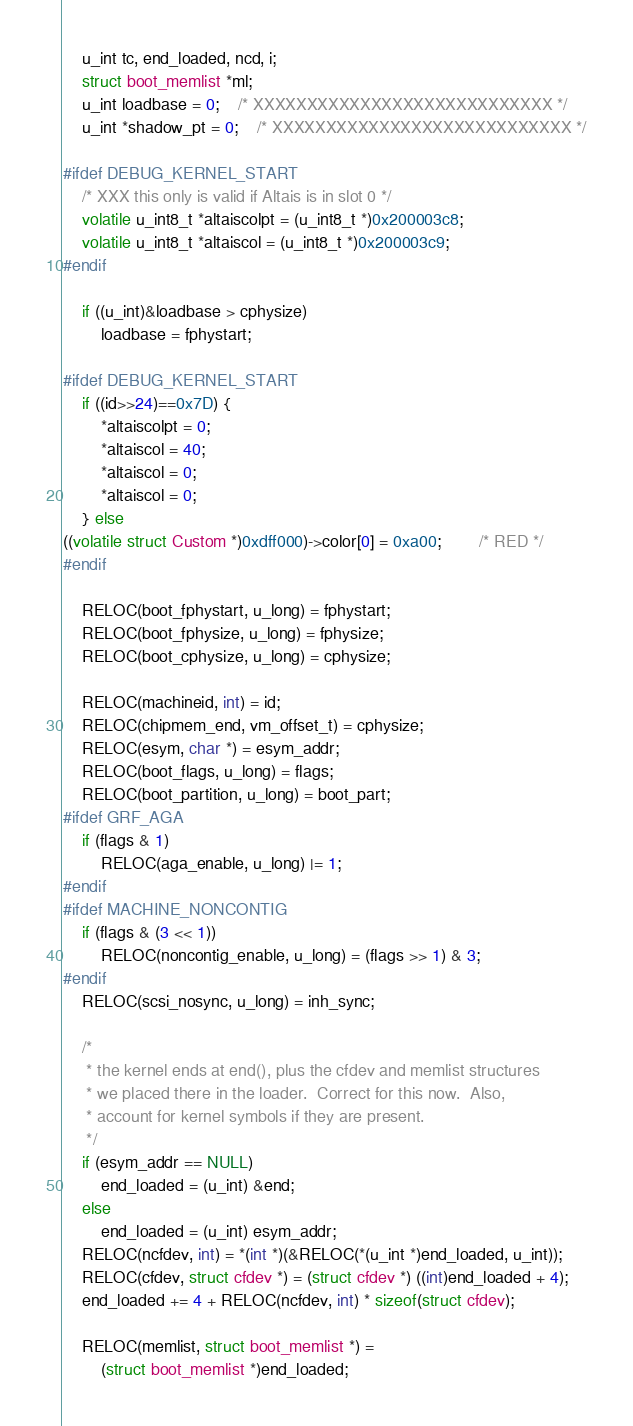<code> <loc_0><loc_0><loc_500><loc_500><_C_>	u_int tc, end_loaded, ncd, i;
	struct boot_memlist *ml;
	u_int loadbase = 0;	/* XXXXXXXXXXXXXXXXXXXXXXXXXXXX */
	u_int *shadow_pt = 0;	/* XXXXXXXXXXXXXXXXXXXXXXXXXXXX */

#ifdef DEBUG_KERNEL_START
	/* XXX this only is valid if Altais is in slot 0 */
	volatile u_int8_t *altaiscolpt = (u_int8_t *)0x200003c8;
	volatile u_int8_t *altaiscol = (u_int8_t *)0x200003c9;
#endif

	if ((u_int)&loadbase > cphysize)
		loadbase = fphystart;

#ifdef DEBUG_KERNEL_START
	if ((id>>24)==0x7D) {
		*altaiscolpt = 0;
		*altaiscol = 40;
		*altaiscol = 0;
		*altaiscol = 0;
	} else
((volatile struct Custom *)0xdff000)->color[0] = 0xa00;		/* RED */
#endif

	RELOC(boot_fphystart, u_long) = fphystart;
	RELOC(boot_fphysize, u_long) = fphysize;
	RELOC(boot_cphysize, u_long) = cphysize;

	RELOC(machineid, int) = id;
	RELOC(chipmem_end, vm_offset_t) = cphysize;
	RELOC(esym, char *) = esym_addr;
	RELOC(boot_flags, u_long) = flags;
	RELOC(boot_partition, u_long) = boot_part;
#ifdef GRF_AGA
	if (flags & 1)
		RELOC(aga_enable, u_long) |= 1;
#endif
#ifdef MACHINE_NONCONTIG
	if (flags & (3 << 1))
		RELOC(noncontig_enable, u_long) = (flags >> 1) & 3;
#endif
	RELOC(scsi_nosync, u_long) = inh_sync;

	/*
	 * the kernel ends at end(), plus the cfdev and memlist structures
	 * we placed there in the loader.  Correct for this now.  Also,
	 * account for kernel symbols if they are present.
	 */
	if (esym_addr == NULL)
		end_loaded = (u_int) &end;
	else
		end_loaded = (u_int) esym_addr;
	RELOC(ncfdev, int) = *(int *)(&RELOC(*(u_int *)end_loaded, u_int));
	RELOC(cfdev, struct cfdev *) = (struct cfdev *) ((int)end_loaded + 4);
	end_loaded += 4 + RELOC(ncfdev, int) * sizeof(struct cfdev);

	RELOC(memlist, struct boot_memlist *) =
	    (struct boot_memlist *)end_loaded;</code> 